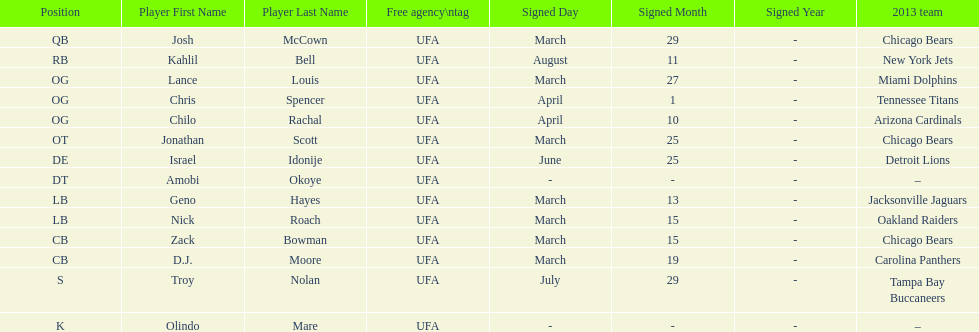Nick roach was signed the same day as what other player? Zack Bowman. 